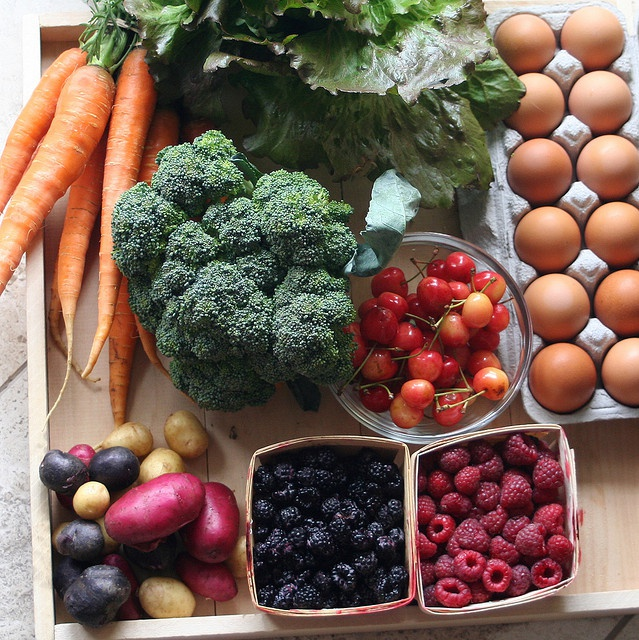Describe the objects in this image and their specific colors. I can see broccoli in white, black, teal, darkgray, and darkgreen tones, bowl in white, maroon, black, brown, and gray tones, carrot in white, tan, orange, and red tones, carrot in white, salmon, tan, and red tones, and carrot in white, orange, tan, and red tones in this image. 